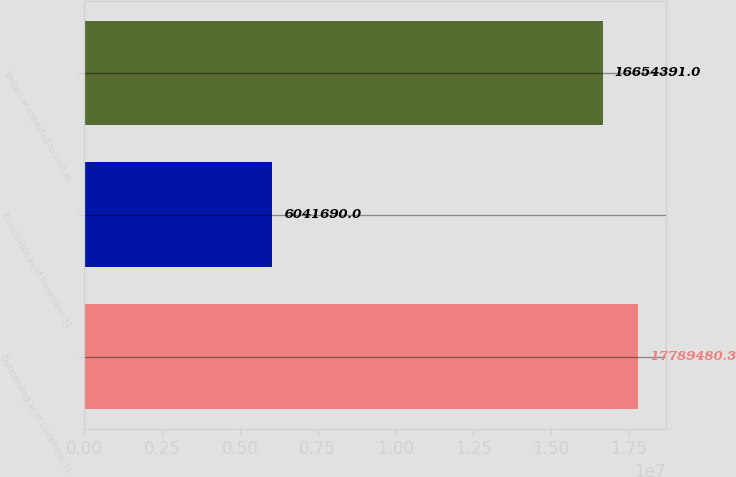<chart> <loc_0><loc_0><loc_500><loc_500><bar_chart><fcel>Outstanding as of December 31<fcel>Exercisable as of December 31<fcel>Vested or expected to vest as<nl><fcel>1.77895e+07<fcel>6.04169e+06<fcel>1.66544e+07<nl></chart> 